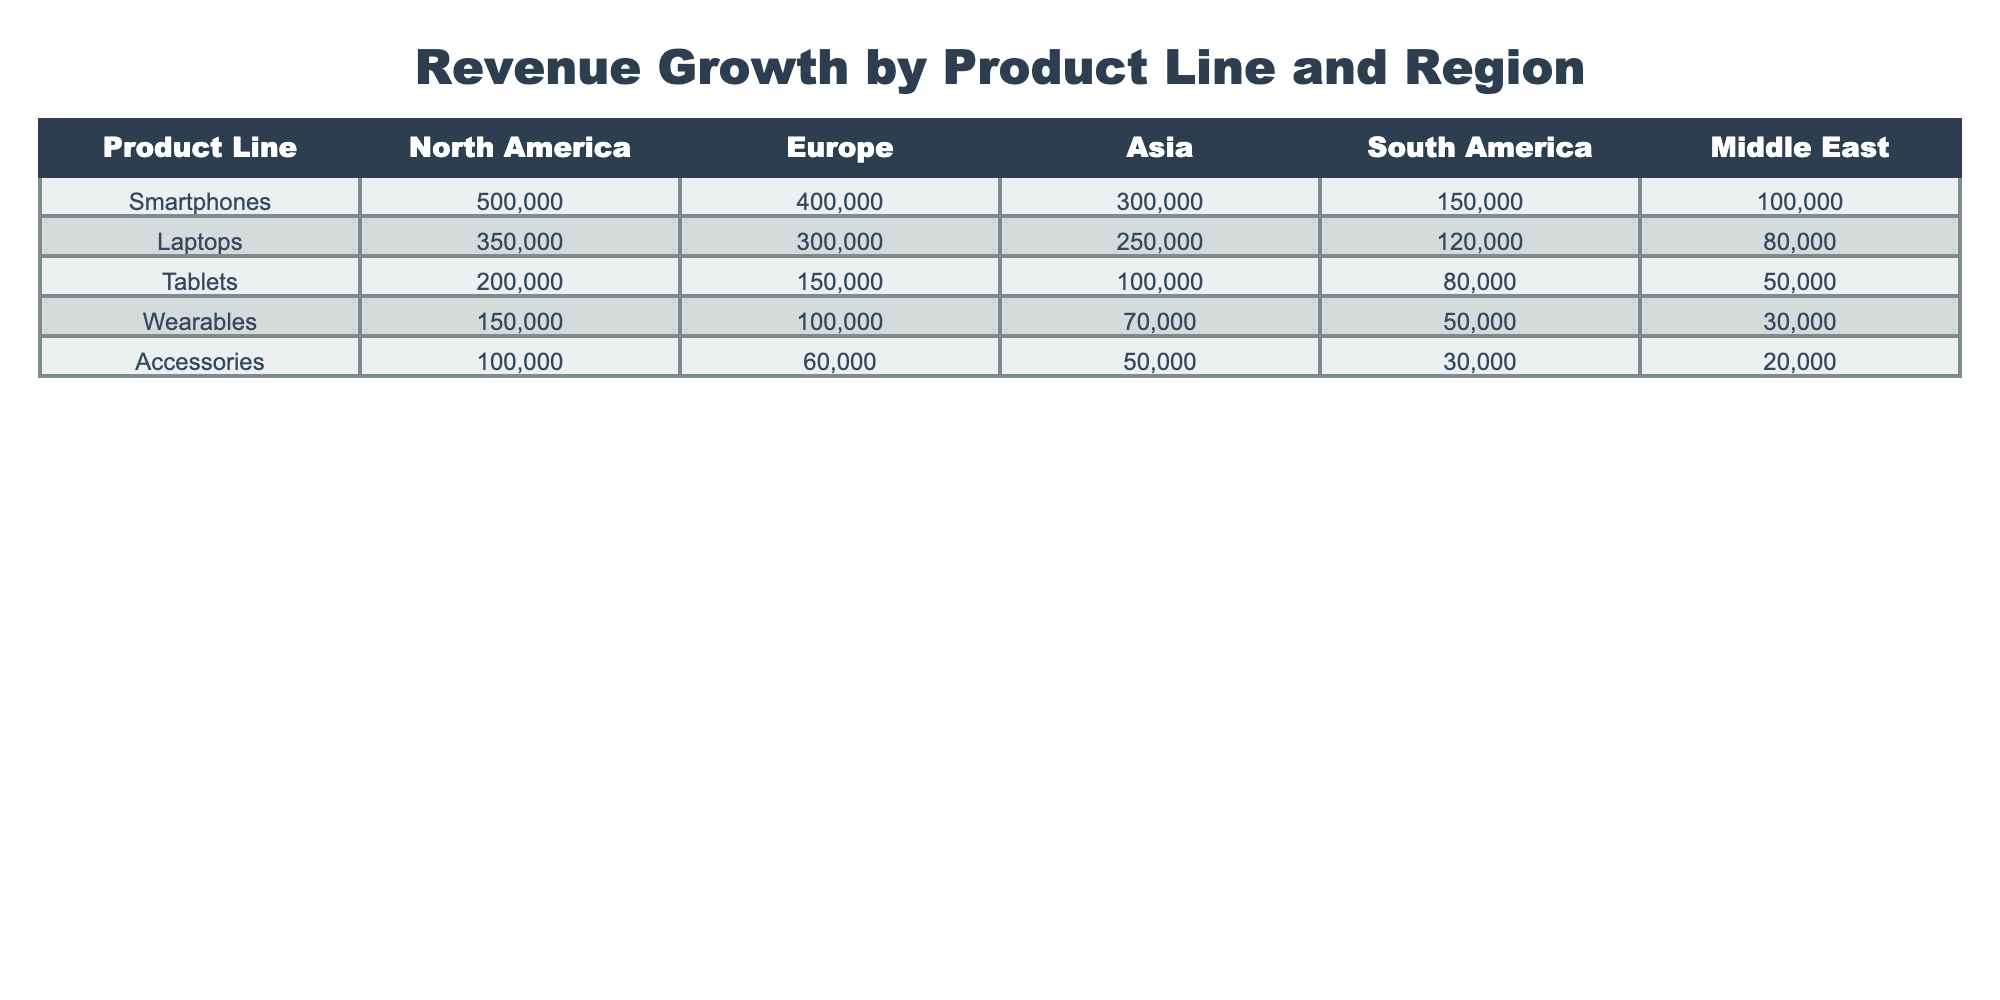What is the revenue for Smartphones in North America? The table shows that the revenue for Smartphones in North America is directly listed under the North America column, where Smartphones is the product line. The value corresponding to this is 500,000.
Answer: 500000 Which product line has the highest revenue in Europe? By examining the Europe column, we can compare the revenues for each product line: Smartphones (400,000), Laptops (300,000), Tablets (150,000), Wearables (100,000), and Accessories (60,000). The highest value is for Smartphones at 400,000.
Answer: Smartphones What is the total revenue for Laptops across all regions? To find the total revenue for Laptops, I add the revenues from all regions: North America (350,000) + Europe (300,000) + Asia (250,000) + South America (120,000) + Middle East (80,000) = 1,100,000.
Answer: 1100000 Is the revenue for Accessories greater than 150,000 in any region? Looking at the Accessories row, the revenues are as follows: North America (100,000), Europe (60,000), Asia (50,000), South America (30,000), and Middle East (20,000). Each of these values is less than 150,000, thus the answer is no.
Answer: No What is the average revenue for Tablets across all regions? First, sum the revenues for Tablets: North America (200,000) + Europe (150,000) + Asia (100,000) + South America (80,000) + Middle East (50,000) = 580,000. There are 5 regions, so the average is 580,000 / 5 = 116,000.
Answer: 116000 Which region has the lowest revenue for Wearables? The Wearables row shows revenues as follows: North America (150,000), Europe (100,000), Asia (70,000), South America (50,000), and Middle East (30,000). The lowest value is in the Middle East at 30,000.
Answer: Middle East If we combine the revenues for Smartphones and Laptops in Asia, what is the total? The revenues for Smartphones and Laptops in Asia are 300,000 and 250,000 respectively. Adding these values together gives 300,000 + 250,000 = 550,000 for the total.
Answer: 550000 Do tablets generate more revenue in Europe than in South America? In Europe, Tablets have a revenue of 150,000 and in South America, they have a revenue of 80,000. Since 150,000 is greater than 80,000, the answer is yes.
Answer: Yes 